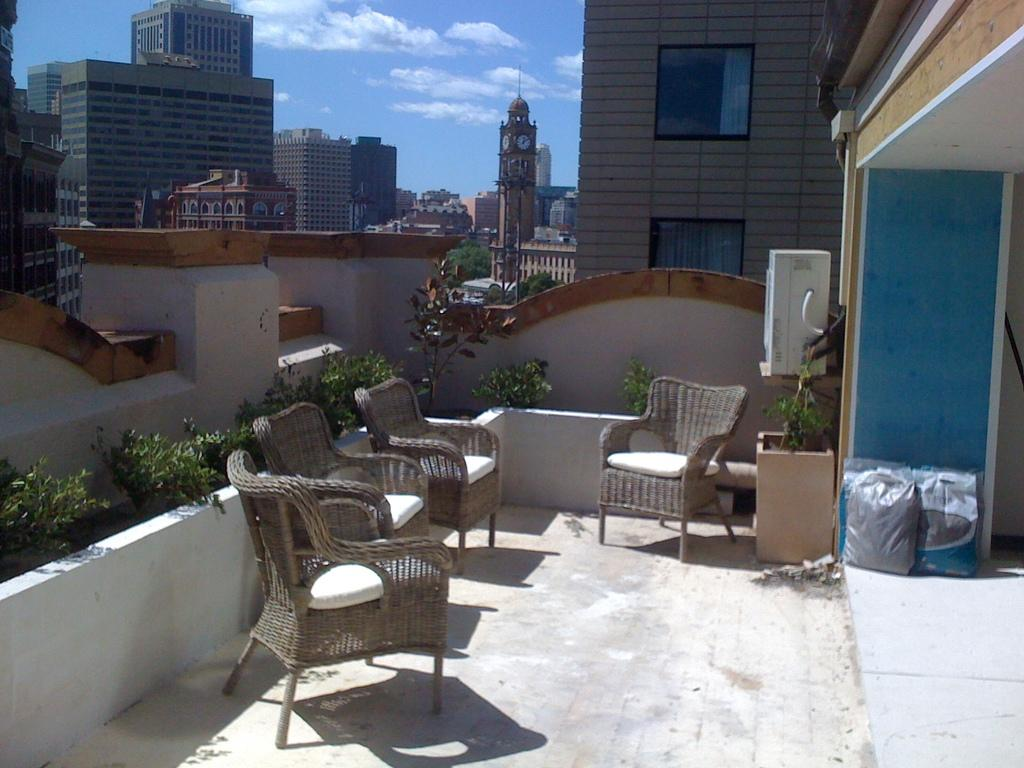What type of furniture is present in the image? There are chairs in the image. What kind of container for plants can be seen in the image? There is a planter in the image. What type of items are present that might be used for carrying or storing things? There are bags in the image. What type of structures are visible in the image? There are buildings in the image. What type of tall structure with a clock can be seen in the image? There is a clock tower in the image. What else can be seen in the image besides the mentioned objects? There are other objects in the image. What is visible in the background of the image? The sky is visible in the background of the image. What type of liquid is leaking from the clock tower in the image? There is no liquid leaking from the clock tower in the image; it is a solid structure. What type of pest can be seen crawling on the bags in the image? There are no pests visible in the image; it only shows chairs, a planter, bags, buildings, a clock tower, other objects, and the sky. 